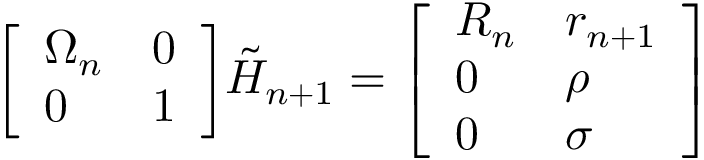<formula> <loc_0><loc_0><loc_500><loc_500>{ \left [ \begin{array} { l l } { \Omega _ { n } } & { 0 } \\ { 0 } & { 1 } \end{array} \right ] } { \tilde { H } } _ { n + 1 } = { \left [ \begin{array} { l l } { R _ { n } } & { r _ { n + 1 } } \\ { 0 } & { \rho } \\ { 0 } & { \sigma } \end{array} \right ] }</formula> 